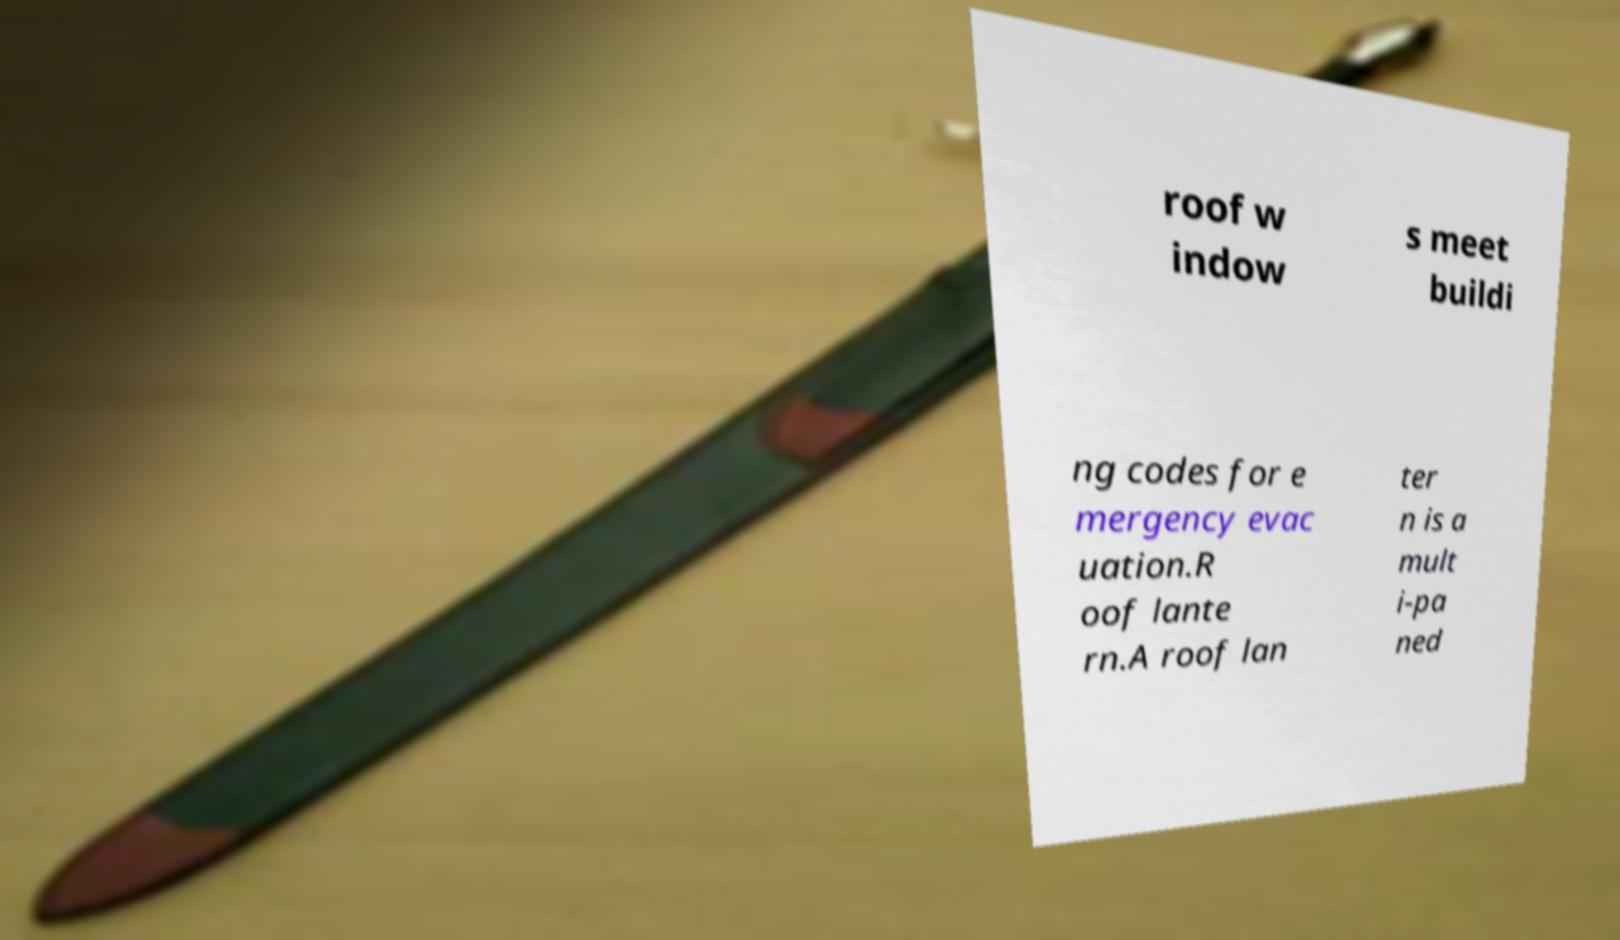Please read and relay the text visible in this image. What does it say? roof w indow s meet buildi ng codes for e mergency evac uation.R oof lante rn.A roof lan ter n is a mult i-pa ned 